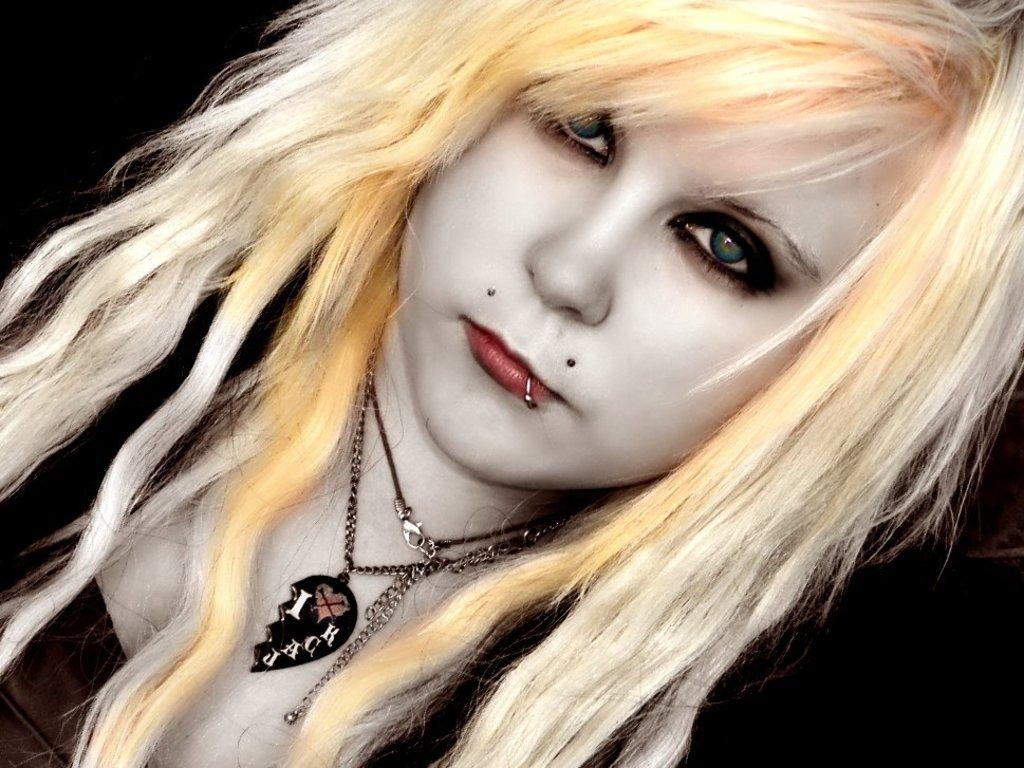Who is present in the image? There is a woman in the image. What is the woman wearing in the image? The woman is wearing accessories. What can be observed about the background of the image? The background of the image is dark. How many beds are visible in the image? There are no beds present in the image. What type of grip does the woman have on the accessory she is wearing? The image does not provide enough detail to determine the type of grip the woman has on the accessory. 